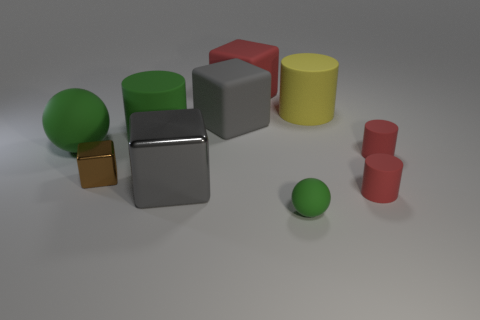Subtract all big green cylinders. How many cylinders are left? 3 Subtract all spheres. How many objects are left? 8 Add 6 cubes. How many cubes are left? 10 Add 4 rubber balls. How many rubber balls exist? 6 Subtract all yellow cylinders. How many cylinders are left? 3 Subtract 1 green spheres. How many objects are left? 9 Subtract 2 balls. How many balls are left? 0 Subtract all yellow balls. Subtract all purple cylinders. How many balls are left? 2 Subtract all blue blocks. How many gray cylinders are left? 0 Subtract all green cylinders. Subtract all large metal cubes. How many objects are left? 8 